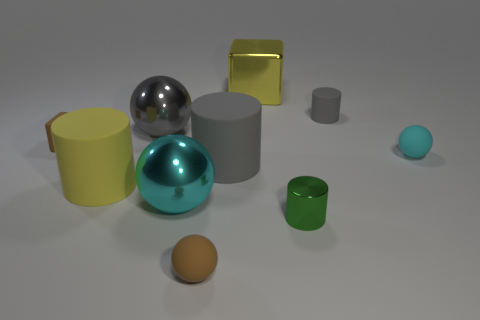Subtract all balls. How many objects are left? 6 Add 8 small cyan spheres. How many small cyan spheres exist? 9 Subtract 1 yellow cylinders. How many objects are left? 9 Subtract all tiny green cylinders. Subtract all shiny objects. How many objects are left? 5 Add 9 big cubes. How many big cubes are left? 10 